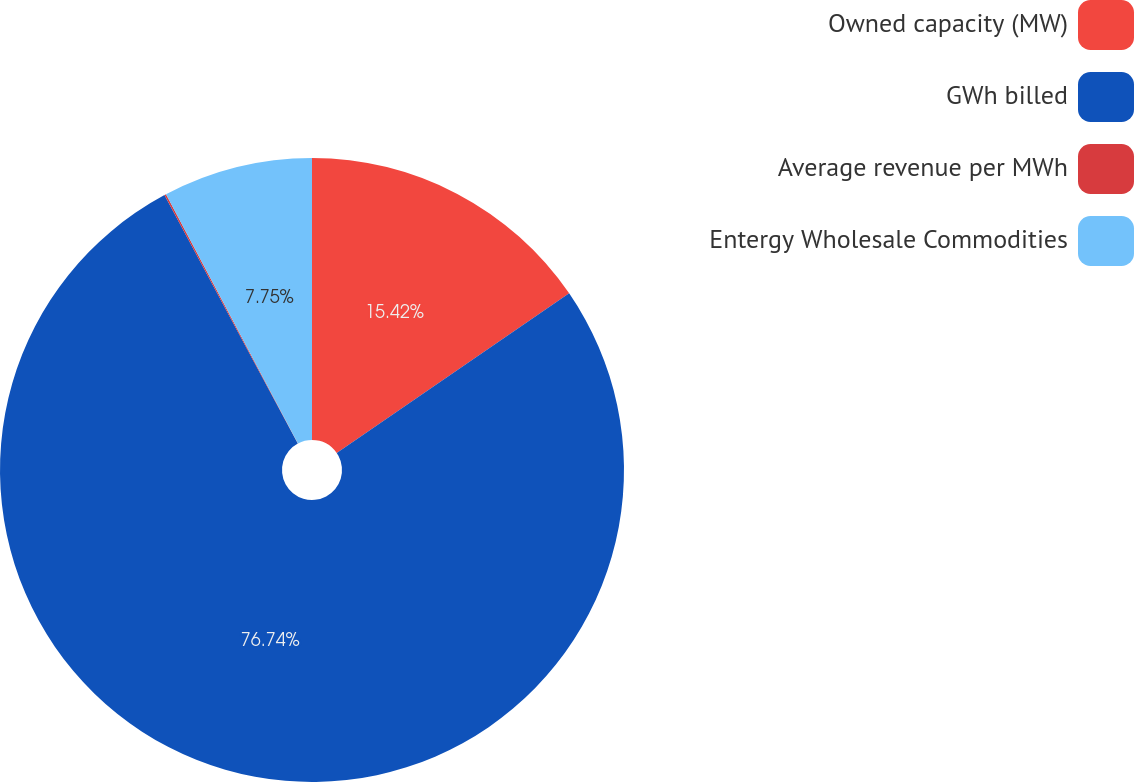Convert chart. <chart><loc_0><loc_0><loc_500><loc_500><pie_chart><fcel>Owned capacity (MW)<fcel>GWh billed<fcel>Average revenue per MWh<fcel>Entergy Wholesale Commodities<nl><fcel>15.42%<fcel>76.74%<fcel>0.09%<fcel>7.75%<nl></chart> 